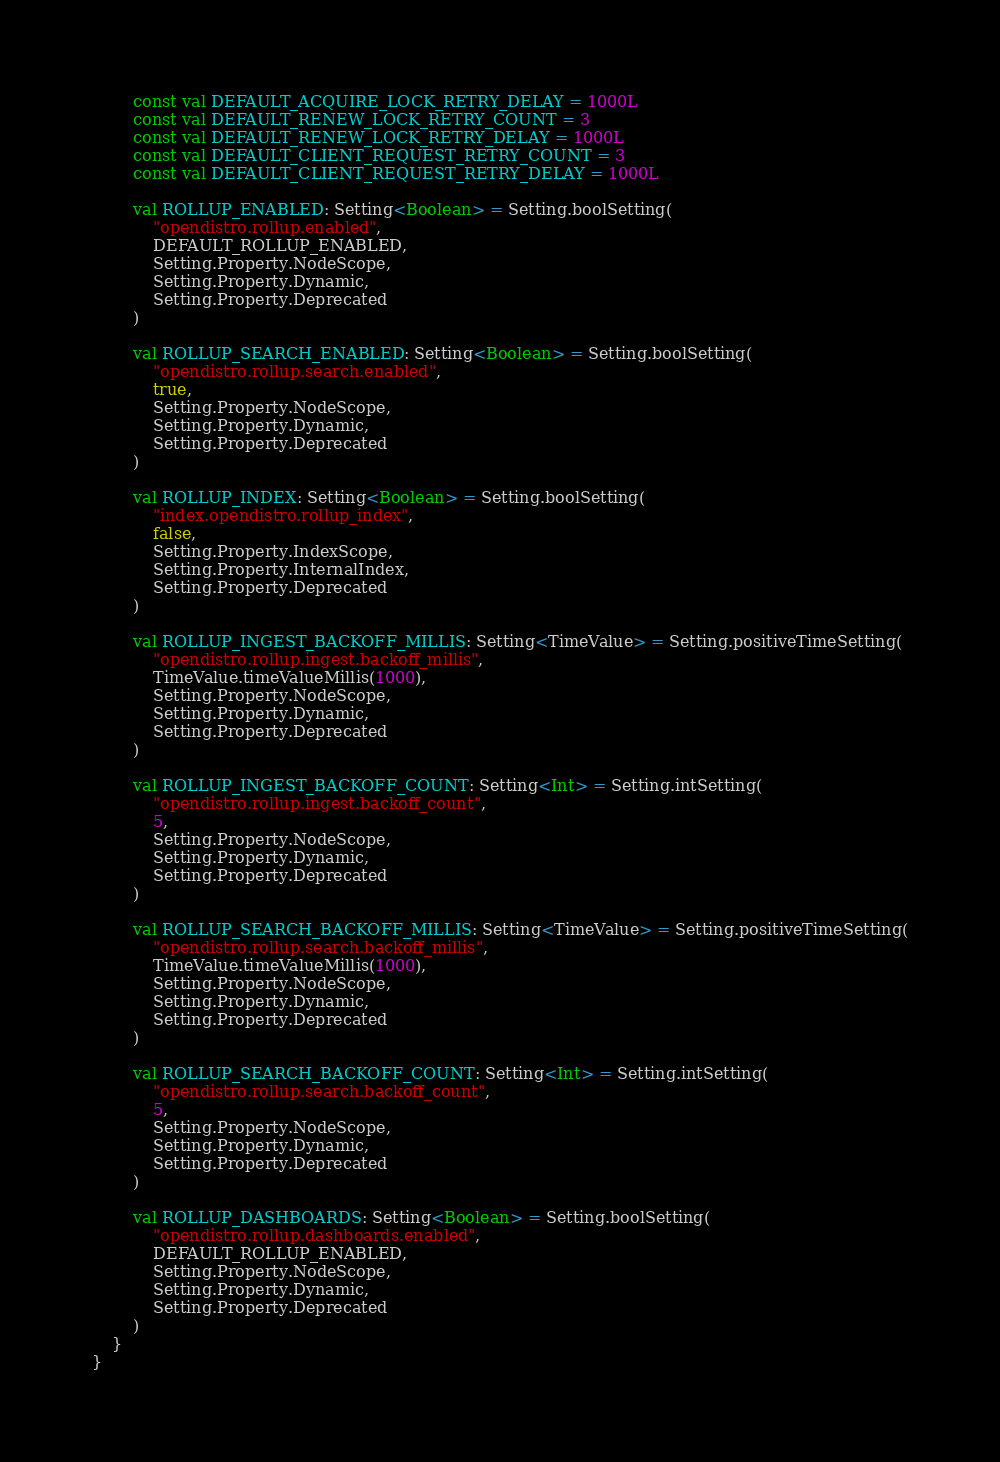Convert code to text. <code><loc_0><loc_0><loc_500><loc_500><_Kotlin_>        const val DEFAULT_ACQUIRE_LOCK_RETRY_DELAY = 1000L
        const val DEFAULT_RENEW_LOCK_RETRY_COUNT = 3
        const val DEFAULT_RENEW_LOCK_RETRY_DELAY = 1000L
        const val DEFAULT_CLIENT_REQUEST_RETRY_COUNT = 3
        const val DEFAULT_CLIENT_REQUEST_RETRY_DELAY = 1000L

        val ROLLUP_ENABLED: Setting<Boolean> = Setting.boolSetting(
            "opendistro.rollup.enabled",
            DEFAULT_ROLLUP_ENABLED,
            Setting.Property.NodeScope,
            Setting.Property.Dynamic,
            Setting.Property.Deprecated
        )

        val ROLLUP_SEARCH_ENABLED: Setting<Boolean> = Setting.boolSetting(
            "opendistro.rollup.search.enabled",
            true,
            Setting.Property.NodeScope,
            Setting.Property.Dynamic,
            Setting.Property.Deprecated
        )

        val ROLLUP_INDEX: Setting<Boolean> = Setting.boolSetting(
            "index.opendistro.rollup_index",
            false,
            Setting.Property.IndexScope,
            Setting.Property.InternalIndex,
            Setting.Property.Deprecated
        )

        val ROLLUP_INGEST_BACKOFF_MILLIS: Setting<TimeValue> = Setting.positiveTimeSetting(
            "opendistro.rollup.ingest.backoff_millis",
            TimeValue.timeValueMillis(1000),
            Setting.Property.NodeScope,
            Setting.Property.Dynamic,
            Setting.Property.Deprecated
        )

        val ROLLUP_INGEST_BACKOFF_COUNT: Setting<Int> = Setting.intSetting(
            "opendistro.rollup.ingest.backoff_count",
            5,
            Setting.Property.NodeScope,
            Setting.Property.Dynamic,
            Setting.Property.Deprecated
        )

        val ROLLUP_SEARCH_BACKOFF_MILLIS: Setting<TimeValue> = Setting.positiveTimeSetting(
            "opendistro.rollup.search.backoff_millis",
            TimeValue.timeValueMillis(1000),
            Setting.Property.NodeScope,
            Setting.Property.Dynamic,
            Setting.Property.Deprecated
        )

        val ROLLUP_SEARCH_BACKOFF_COUNT: Setting<Int> = Setting.intSetting(
            "opendistro.rollup.search.backoff_count",
            5,
            Setting.Property.NodeScope,
            Setting.Property.Dynamic,
            Setting.Property.Deprecated
        )

        val ROLLUP_DASHBOARDS: Setting<Boolean> = Setting.boolSetting(
            "opendistro.rollup.dashboards.enabled",
            DEFAULT_ROLLUP_ENABLED,
            Setting.Property.NodeScope,
            Setting.Property.Dynamic,
            Setting.Property.Deprecated
        )
    }
}
</code> 